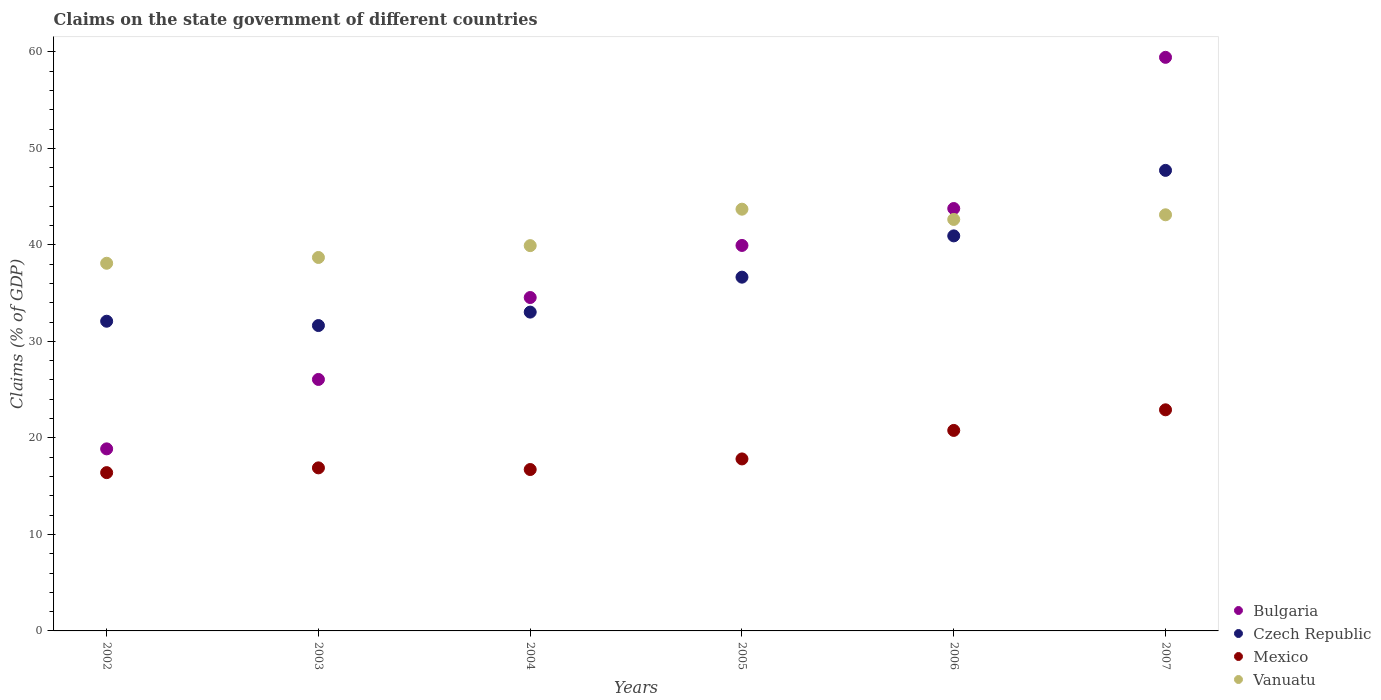What is the percentage of GDP claimed on the state government in Vanuatu in 2003?
Provide a short and direct response. 38.69. Across all years, what is the maximum percentage of GDP claimed on the state government in Czech Republic?
Offer a very short reply. 47.72. Across all years, what is the minimum percentage of GDP claimed on the state government in Czech Republic?
Provide a succinct answer. 31.64. What is the total percentage of GDP claimed on the state government in Czech Republic in the graph?
Keep it short and to the point. 222.06. What is the difference between the percentage of GDP claimed on the state government in Vanuatu in 2002 and that in 2006?
Make the answer very short. -4.54. What is the difference between the percentage of GDP claimed on the state government in Mexico in 2002 and the percentage of GDP claimed on the state government in Vanuatu in 2007?
Your response must be concise. -26.72. What is the average percentage of GDP claimed on the state government in Mexico per year?
Provide a succinct answer. 18.59. In the year 2003, what is the difference between the percentage of GDP claimed on the state government in Bulgaria and percentage of GDP claimed on the state government in Czech Republic?
Your response must be concise. -5.58. In how many years, is the percentage of GDP claimed on the state government in Czech Republic greater than 22 %?
Provide a short and direct response. 6. What is the ratio of the percentage of GDP claimed on the state government in Mexico in 2002 to that in 2006?
Your answer should be compact. 0.79. Is the percentage of GDP claimed on the state government in Mexico in 2004 less than that in 2007?
Provide a succinct answer. Yes. What is the difference between the highest and the second highest percentage of GDP claimed on the state government in Bulgaria?
Offer a very short reply. 15.66. What is the difference between the highest and the lowest percentage of GDP claimed on the state government in Czech Republic?
Provide a succinct answer. 16.08. Is the percentage of GDP claimed on the state government in Czech Republic strictly less than the percentage of GDP claimed on the state government in Vanuatu over the years?
Provide a succinct answer. No. How many dotlines are there?
Offer a terse response. 4. What is the difference between two consecutive major ticks on the Y-axis?
Your response must be concise. 10. Are the values on the major ticks of Y-axis written in scientific E-notation?
Provide a short and direct response. No. Where does the legend appear in the graph?
Make the answer very short. Bottom right. How many legend labels are there?
Provide a succinct answer. 4. What is the title of the graph?
Your answer should be compact. Claims on the state government of different countries. What is the label or title of the Y-axis?
Your response must be concise. Claims (% of GDP). What is the Claims (% of GDP) in Bulgaria in 2002?
Your response must be concise. 18.86. What is the Claims (% of GDP) of Czech Republic in 2002?
Offer a terse response. 32.09. What is the Claims (% of GDP) of Mexico in 2002?
Make the answer very short. 16.4. What is the Claims (% of GDP) in Vanuatu in 2002?
Keep it short and to the point. 38.09. What is the Claims (% of GDP) of Bulgaria in 2003?
Provide a succinct answer. 26.06. What is the Claims (% of GDP) of Czech Republic in 2003?
Make the answer very short. 31.64. What is the Claims (% of GDP) in Mexico in 2003?
Your response must be concise. 16.89. What is the Claims (% of GDP) of Vanuatu in 2003?
Provide a short and direct response. 38.69. What is the Claims (% of GDP) of Bulgaria in 2004?
Ensure brevity in your answer.  34.54. What is the Claims (% of GDP) in Czech Republic in 2004?
Offer a terse response. 33.03. What is the Claims (% of GDP) of Mexico in 2004?
Your answer should be very brief. 16.72. What is the Claims (% of GDP) in Vanuatu in 2004?
Your answer should be compact. 39.92. What is the Claims (% of GDP) in Bulgaria in 2005?
Offer a terse response. 39.94. What is the Claims (% of GDP) in Czech Republic in 2005?
Provide a short and direct response. 36.65. What is the Claims (% of GDP) of Mexico in 2005?
Ensure brevity in your answer.  17.82. What is the Claims (% of GDP) in Vanuatu in 2005?
Ensure brevity in your answer.  43.7. What is the Claims (% of GDP) of Bulgaria in 2006?
Make the answer very short. 43.77. What is the Claims (% of GDP) of Czech Republic in 2006?
Offer a terse response. 40.93. What is the Claims (% of GDP) in Mexico in 2006?
Your response must be concise. 20.77. What is the Claims (% of GDP) in Vanuatu in 2006?
Provide a short and direct response. 42.63. What is the Claims (% of GDP) in Bulgaria in 2007?
Give a very brief answer. 59.43. What is the Claims (% of GDP) of Czech Republic in 2007?
Ensure brevity in your answer.  47.72. What is the Claims (% of GDP) of Mexico in 2007?
Provide a succinct answer. 22.91. What is the Claims (% of GDP) of Vanuatu in 2007?
Your response must be concise. 43.12. Across all years, what is the maximum Claims (% of GDP) in Bulgaria?
Provide a short and direct response. 59.43. Across all years, what is the maximum Claims (% of GDP) in Czech Republic?
Provide a succinct answer. 47.72. Across all years, what is the maximum Claims (% of GDP) of Mexico?
Give a very brief answer. 22.91. Across all years, what is the maximum Claims (% of GDP) in Vanuatu?
Your answer should be very brief. 43.7. Across all years, what is the minimum Claims (% of GDP) in Bulgaria?
Your answer should be compact. 18.86. Across all years, what is the minimum Claims (% of GDP) in Czech Republic?
Your response must be concise. 31.64. Across all years, what is the minimum Claims (% of GDP) in Mexico?
Keep it short and to the point. 16.4. Across all years, what is the minimum Claims (% of GDP) in Vanuatu?
Your response must be concise. 38.09. What is the total Claims (% of GDP) in Bulgaria in the graph?
Offer a very short reply. 222.6. What is the total Claims (% of GDP) in Czech Republic in the graph?
Your response must be concise. 222.06. What is the total Claims (% of GDP) in Mexico in the graph?
Give a very brief answer. 111.52. What is the total Claims (% of GDP) of Vanuatu in the graph?
Provide a succinct answer. 246.15. What is the difference between the Claims (% of GDP) of Bulgaria in 2002 and that in 2003?
Make the answer very short. -7.19. What is the difference between the Claims (% of GDP) of Czech Republic in 2002 and that in 2003?
Your response must be concise. 0.45. What is the difference between the Claims (% of GDP) in Mexico in 2002 and that in 2003?
Make the answer very short. -0.49. What is the difference between the Claims (% of GDP) of Vanuatu in 2002 and that in 2003?
Provide a succinct answer. -0.6. What is the difference between the Claims (% of GDP) of Bulgaria in 2002 and that in 2004?
Ensure brevity in your answer.  -15.68. What is the difference between the Claims (% of GDP) of Czech Republic in 2002 and that in 2004?
Your answer should be compact. -0.94. What is the difference between the Claims (% of GDP) of Mexico in 2002 and that in 2004?
Provide a succinct answer. -0.32. What is the difference between the Claims (% of GDP) of Vanuatu in 2002 and that in 2004?
Make the answer very short. -1.83. What is the difference between the Claims (% of GDP) in Bulgaria in 2002 and that in 2005?
Offer a very short reply. -21.08. What is the difference between the Claims (% of GDP) in Czech Republic in 2002 and that in 2005?
Give a very brief answer. -4.57. What is the difference between the Claims (% of GDP) in Mexico in 2002 and that in 2005?
Provide a short and direct response. -1.42. What is the difference between the Claims (% of GDP) of Vanuatu in 2002 and that in 2005?
Your response must be concise. -5.6. What is the difference between the Claims (% of GDP) in Bulgaria in 2002 and that in 2006?
Offer a terse response. -24.9. What is the difference between the Claims (% of GDP) of Czech Republic in 2002 and that in 2006?
Ensure brevity in your answer.  -8.84. What is the difference between the Claims (% of GDP) in Mexico in 2002 and that in 2006?
Your answer should be very brief. -4.37. What is the difference between the Claims (% of GDP) in Vanuatu in 2002 and that in 2006?
Your answer should be compact. -4.54. What is the difference between the Claims (% of GDP) of Bulgaria in 2002 and that in 2007?
Offer a very short reply. -40.57. What is the difference between the Claims (% of GDP) of Czech Republic in 2002 and that in 2007?
Provide a succinct answer. -15.63. What is the difference between the Claims (% of GDP) of Mexico in 2002 and that in 2007?
Give a very brief answer. -6.51. What is the difference between the Claims (% of GDP) in Vanuatu in 2002 and that in 2007?
Provide a succinct answer. -5.02. What is the difference between the Claims (% of GDP) of Bulgaria in 2003 and that in 2004?
Offer a terse response. -8.49. What is the difference between the Claims (% of GDP) of Czech Republic in 2003 and that in 2004?
Provide a short and direct response. -1.39. What is the difference between the Claims (% of GDP) in Mexico in 2003 and that in 2004?
Make the answer very short. 0.17. What is the difference between the Claims (% of GDP) of Vanuatu in 2003 and that in 2004?
Your answer should be compact. -1.23. What is the difference between the Claims (% of GDP) in Bulgaria in 2003 and that in 2005?
Provide a short and direct response. -13.88. What is the difference between the Claims (% of GDP) of Czech Republic in 2003 and that in 2005?
Offer a very short reply. -5.01. What is the difference between the Claims (% of GDP) of Mexico in 2003 and that in 2005?
Give a very brief answer. -0.93. What is the difference between the Claims (% of GDP) of Vanuatu in 2003 and that in 2005?
Provide a succinct answer. -5. What is the difference between the Claims (% of GDP) in Bulgaria in 2003 and that in 2006?
Ensure brevity in your answer.  -17.71. What is the difference between the Claims (% of GDP) of Czech Republic in 2003 and that in 2006?
Your answer should be compact. -9.29. What is the difference between the Claims (% of GDP) of Mexico in 2003 and that in 2006?
Offer a terse response. -3.88. What is the difference between the Claims (% of GDP) of Vanuatu in 2003 and that in 2006?
Provide a short and direct response. -3.94. What is the difference between the Claims (% of GDP) in Bulgaria in 2003 and that in 2007?
Make the answer very short. -33.37. What is the difference between the Claims (% of GDP) in Czech Republic in 2003 and that in 2007?
Keep it short and to the point. -16.08. What is the difference between the Claims (% of GDP) of Mexico in 2003 and that in 2007?
Give a very brief answer. -6.02. What is the difference between the Claims (% of GDP) of Vanuatu in 2003 and that in 2007?
Keep it short and to the point. -4.42. What is the difference between the Claims (% of GDP) in Bulgaria in 2004 and that in 2005?
Your answer should be compact. -5.4. What is the difference between the Claims (% of GDP) in Czech Republic in 2004 and that in 2005?
Make the answer very short. -3.62. What is the difference between the Claims (% of GDP) in Mexico in 2004 and that in 2005?
Ensure brevity in your answer.  -1.1. What is the difference between the Claims (% of GDP) in Vanuatu in 2004 and that in 2005?
Give a very brief answer. -3.78. What is the difference between the Claims (% of GDP) in Bulgaria in 2004 and that in 2006?
Provide a short and direct response. -9.22. What is the difference between the Claims (% of GDP) of Czech Republic in 2004 and that in 2006?
Give a very brief answer. -7.9. What is the difference between the Claims (% of GDP) of Mexico in 2004 and that in 2006?
Give a very brief answer. -4.05. What is the difference between the Claims (% of GDP) of Vanuatu in 2004 and that in 2006?
Keep it short and to the point. -2.71. What is the difference between the Claims (% of GDP) in Bulgaria in 2004 and that in 2007?
Your answer should be compact. -24.89. What is the difference between the Claims (% of GDP) in Czech Republic in 2004 and that in 2007?
Make the answer very short. -14.68. What is the difference between the Claims (% of GDP) in Mexico in 2004 and that in 2007?
Your answer should be compact. -6.19. What is the difference between the Claims (% of GDP) of Vanuatu in 2004 and that in 2007?
Your answer should be compact. -3.2. What is the difference between the Claims (% of GDP) in Bulgaria in 2005 and that in 2006?
Keep it short and to the point. -3.82. What is the difference between the Claims (% of GDP) of Czech Republic in 2005 and that in 2006?
Your answer should be compact. -4.28. What is the difference between the Claims (% of GDP) in Mexico in 2005 and that in 2006?
Make the answer very short. -2.95. What is the difference between the Claims (% of GDP) in Vanuatu in 2005 and that in 2006?
Offer a very short reply. 1.06. What is the difference between the Claims (% of GDP) of Bulgaria in 2005 and that in 2007?
Ensure brevity in your answer.  -19.49. What is the difference between the Claims (% of GDP) of Czech Republic in 2005 and that in 2007?
Your answer should be very brief. -11.06. What is the difference between the Claims (% of GDP) of Mexico in 2005 and that in 2007?
Your response must be concise. -5.09. What is the difference between the Claims (% of GDP) of Vanuatu in 2005 and that in 2007?
Ensure brevity in your answer.  0.58. What is the difference between the Claims (% of GDP) in Bulgaria in 2006 and that in 2007?
Your answer should be compact. -15.66. What is the difference between the Claims (% of GDP) of Czech Republic in 2006 and that in 2007?
Give a very brief answer. -6.79. What is the difference between the Claims (% of GDP) in Mexico in 2006 and that in 2007?
Your answer should be compact. -2.14. What is the difference between the Claims (% of GDP) of Vanuatu in 2006 and that in 2007?
Your response must be concise. -0.48. What is the difference between the Claims (% of GDP) of Bulgaria in 2002 and the Claims (% of GDP) of Czech Republic in 2003?
Your answer should be compact. -12.78. What is the difference between the Claims (% of GDP) in Bulgaria in 2002 and the Claims (% of GDP) in Mexico in 2003?
Your answer should be compact. 1.97. What is the difference between the Claims (% of GDP) of Bulgaria in 2002 and the Claims (% of GDP) of Vanuatu in 2003?
Keep it short and to the point. -19.83. What is the difference between the Claims (% of GDP) of Czech Republic in 2002 and the Claims (% of GDP) of Mexico in 2003?
Ensure brevity in your answer.  15.19. What is the difference between the Claims (% of GDP) of Czech Republic in 2002 and the Claims (% of GDP) of Vanuatu in 2003?
Your answer should be very brief. -6.61. What is the difference between the Claims (% of GDP) of Mexico in 2002 and the Claims (% of GDP) of Vanuatu in 2003?
Your answer should be very brief. -22.29. What is the difference between the Claims (% of GDP) in Bulgaria in 2002 and the Claims (% of GDP) in Czech Republic in 2004?
Your answer should be very brief. -14.17. What is the difference between the Claims (% of GDP) in Bulgaria in 2002 and the Claims (% of GDP) in Mexico in 2004?
Your answer should be compact. 2.14. What is the difference between the Claims (% of GDP) in Bulgaria in 2002 and the Claims (% of GDP) in Vanuatu in 2004?
Provide a succinct answer. -21.06. What is the difference between the Claims (% of GDP) of Czech Republic in 2002 and the Claims (% of GDP) of Mexico in 2004?
Give a very brief answer. 15.37. What is the difference between the Claims (% of GDP) of Czech Republic in 2002 and the Claims (% of GDP) of Vanuatu in 2004?
Provide a succinct answer. -7.83. What is the difference between the Claims (% of GDP) of Mexico in 2002 and the Claims (% of GDP) of Vanuatu in 2004?
Provide a short and direct response. -23.52. What is the difference between the Claims (% of GDP) in Bulgaria in 2002 and the Claims (% of GDP) in Czech Republic in 2005?
Provide a short and direct response. -17.79. What is the difference between the Claims (% of GDP) in Bulgaria in 2002 and the Claims (% of GDP) in Mexico in 2005?
Make the answer very short. 1.04. What is the difference between the Claims (% of GDP) of Bulgaria in 2002 and the Claims (% of GDP) of Vanuatu in 2005?
Keep it short and to the point. -24.83. What is the difference between the Claims (% of GDP) of Czech Republic in 2002 and the Claims (% of GDP) of Mexico in 2005?
Give a very brief answer. 14.27. What is the difference between the Claims (% of GDP) of Czech Republic in 2002 and the Claims (% of GDP) of Vanuatu in 2005?
Make the answer very short. -11.61. What is the difference between the Claims (% of GDP) in Mexico in 2002 and the Claims (% of GDP) in Vanuatu in 2005?
Provide a succinct answer. -27.3. What is the difference between the Claims (% of GDP) in Bulgaria in 2002 and the Claims (% of GDP) in Czech Republic in 2006?
Keep it short and to the point. -22.07. What is the difference between the Claims (% of GDP) in Bulgaria in 2002 and the Claims (% of GDP) in Mexico in 2006?
Your answer should be compact. -1.91. What is the difference between the Claims (% of GDP) of Bulgaria in 2002 and the Claims (% of GDP) of Vanuatu in 2006?
Offer a very short reply. -23.77. What is the difference between the Claims (% of GDP) of Czech Republic in 2002 and the Claims (% of GDP) of Mexico in 2006?
Offer a very short reply. 11.31. What is the difference between the Claims (% of GDP) of Czech Republic in 2002 and the Claims (% of GDP) of Vanuatu in 2006?
Keep it short and to the point. -10.55. What is the difference between the Claims (% of GDP) of Mexico in 2002 and the Claims (% of GDP) of Vanuatu in 2006?
Give a very brief answer. -26.23. What is the difference between the Claims (% of GDP) of Bulgaria in 2002 and the Claims (% of GDP) of Czech Republic in 2007?
Make the answer very short. -28.86. What is the difference between the Claims (% of GDP) in Bulgaria in 2002 and the Claims (% of GDP) in Mexico in 2007?
Offer a very short reply. -4.05. What is the difference between the Claims (% of GDP) of Bulgaria in 2002 and the Claims (% of GDP) of Vanuatu in 2007?
Your answer should be compact. -24.25. What is the difference between the Claims (% of GDP) of Czech Republic in 2002 and the Claims (% of GDP) of Mexico in 2007?
Your response must be concise. 9.18. What is the difference between the Claims (% of GDP) in Czech Republic in 2002 and the Claims (% of GDP) in Vanuatu in 2007?
Your response must be concise. -11.03. What is the difference between the Claims (% of GDP) of Mexico in 2002 and the Claims (% of GDP) of Vanuatu in 2007?
Your response must be concise. -26.72. What is the difference between the Claims (% of GDP) of Bulgaria in 2003 and the Claims (% of GDP) of Czech Republic in 2004?
Give a very brief answer. -6.98. What is the difference between the Claims (% of GDP) of Bulgaria in 2003 and the Claims (% of GDP) of Mexico in 2004?
Offer a very short reply. 9.33. What is the difference between the Claims (% of GDP) in Bulgaria in 2003 and the Claims (% of GDP) in Vanuatu in 2004?
Offer a terse response. -13.86. What is the difference between the Claims (% of GDP) of Czech Republic in 2003 and the Claims (% of GDP) of Mexico in 2004?
Provide a succinct answer. 14.92. What is the difference between the Claims (% of GDP) of Czech Republic in 2003 and the Claims (% of GDP) of Vanuatu in 2004?
Your answer should be compact. -8.28. What is the difference between the Claims (% of GDP) in Mexico in 2003 and the Claims (% of GDP) in Vanuatu in 2004?
Make the answer very short. -23.03. What is the difference between the Claims (% of GDP) of Bulgaria in 2003 and the Claims (% of GDP) of Czech Republic in 2005?
Offer a very short reply. -10.6. What is the difference between the Claims (% of GDP) in Bulgaria in 2003 and the Claims (% of GDP) in Mexico in 2005?
Your response must be concise. 8.23. What is the difference between the Claims (% of GDP) in Bulgaria in 2003 and the Claims (% of GDP) in Vanuatu in 2005?
Offer a very short reply. -17.64. What is the difference between the Claims (% of GDP) in Czech Republic in 2003 and the Claims (% of GDP) in Mexico in 2005?
Provide a short and direct response. 13.82. What is the difference between the Claims (% of GDP) of Czech Republic in 2003 and the Claims (% of GDP) of Vanuatu in 2005?
Provide a short and direct response. -12.06. What is the difference between the Claims (% of GDP) of Mexico in 2003 and the Claims (% of GDP) of Vanuatu in 2005?
Provide a succinct answer. -26.8. What is the difference between the Claims (% of GDP) in Bulgaria in 2003 and the Claims (% of GDP) in Czech Republic in 2006?
Your response must be concise. -14.88. What is the difference between the Claims (% of GDP) in Bulgaria in 2003 and the Claims (% of GDP) in Mexico in 2006?
Your answer should be compact. 5.28. What is the difference between the Claims (% of GDP) in Bulgaria in 2003 and the Claims (% of GDP) in Vanuatu in 2006?
Ensure brevity in your answer.  -16.58. What is the difference between the Claims (% of GDP) of Czech Republic in 2003 and the Claims (% of GDP) of Mexico in 2006?
Offer a terse response. 10.87. What is the difference between the Claims (% of GDP) in Czech Republic in 2003 and the Claims (% of GDP) in Vanuatu in 2006?
Keep it short and to the point. -10.99. What is the difference between the Claims (% of GDP) of Mexico in 2003 and the Claims (% of GDP) of Vanuatu in 2006?
Give a very brief answer. -25.74. What is the difference between the Claims (% of GDP) in Bulgaria in 2003 and the Claims (% of GDP) in Czech Republic in 2007?
Your answer should be very brief. -21.66. What is the difference between the Claims (% of GDP) in Bulgaria in 2003 and the Claims (% of GDP) in Mexico in 2007?
Your answer should be very brief. 3.15. What is the difference between the Claims (% of GDP) of Bulgaria in 2003 and the Claims (% of GDP) of Vanuatu in 2007?
Give a very brief answer. -17.06. What is the difference between the Claims (% of GDP) in Czech Republic in 2003 and the Claims (% of GDP) in Mexico in 2007?
Give a very brief answer. 8.73. What is the difference between the Claims (% of GDP) in Czech Republic in 2003 and the Claims (% of GDP) in Vanuatu in 2007?
Keep it short and to the point. -11.48. What is the difference between the Claims (% of GDP) of Mexico in 2003 and the Claims (% of GDP) of Vanuatu in 2007?
Offer a very short reply. -26.22. What is the difference between the Claims (% of GDP) in Bulgaria in 2004 and the Claims (% of GDP) in Czech Republic in 2005?
Your answer should be compact. -2.11. What is the difference between the Claims (% of GDP) of Bulgaria in 2004 and the Claims (% of GDP) of Mexico in 2005?
Your answer should be compact. 16.72. What is the difference between the Claims (% of GDP) in Bulgaria in 2004 and the Claims (% of GDP) in Vanuatu in 2005?
Provide a short and direct response. -9.15. What is the difference between the Claims (% of GDP) of Czech Republic in 2004 and the Claims (% of GDP) of Mexico in 2005?
Make the answer very short. 15.21. What is the difference between the Claims (% of GDP) in Czech Republic in 2004 and the Claims (% of GDP) in Vanuatu in 2005?
Your response must be concise. -10.66. What is the difference between the Claims (% of GDP) of Mexico in 2004 and the Claims (% of GDP) of Vanuatu in 2005?
Provide a succinct answer. -26.97. What is the difference between the Claims (% of GDP) in Bulgaria in 2004 and the Claims (% of GDP) in Czech Republic in 2006?
Ensure brevity in your answer.  -6.39. What is the difference between the Claims (% of GDP) of Bulgaria in 2004 and the Claims (% of GDP) of Mexico in 2006?
Provide a short and direct response. 13.77. What is the difference between the Claims (% of GDP) in Bulgaria in 2004 and the Claims (% of GDP) in Vanuatu in 2006?
Ensure brevity in your answer.  -8.09. What is the difference between the Claims (% of GDP) of Czech Republic in 2004 and the Claims (% of GDP) of Mexico in 2006?
Keep it short and to the point. 12.26. What is the difference between the Claims (% of GDP) in Czech Republic in 2004 and the Claims (% of GDP) in Vanuatu in 2006?
Make the answer very short. -9.6. What is the difference between the Claims (% of GDP) in Mexico in 2004 and the Claims (% of GDP) in Vanuatu in 2006?
Ensure brevity in your answer.  -25.91. What is the difference between the Claims (% of GDP) in Bulgaria in 2004 and the Claims (% of GDP) in Czech Republic in 2007?
Make the answer very short. -13.17. What is the difference between the Claims (% of GDP) in Bulgaria in 2004 and the Claims (% of GDP) in Mexico in 2007?
Your answer should be very brief. 11.63. What is the difference between the Claims (% of GDP) in Bulgaria in 2004 and the Claims (% of GDP) in Vanuatu in 2007?
Give a very brief answer. -8.57. What is the difference between the Claims (% of GDP) of Czech Republic in 2004 and the Claims (% of GDP) of Mexico in 2007?
Keep it short and to the point. 10.12. What is the difference between the Claims (% of GDP) in Czech Republic in 2004 and the Claims (% of GDP) in Vanuatu in 2007?
Provide a succinct answer. -10.08. What is the difference between the Claims (% of GDP) in Mexico in 2004 and the Claims (% of GDP) in Vanuatu in 2007?
Keep it short and to the point. -26.39. What is the difference between the Claims (% of GDP) of Bulgaria in 2005 and the Claims (% of GDP) of Czech Republic in 2006?
Offer a terse response. -0.99. What is the difference between the Claims (% of GDP) of Bulgaria in 2005 and the Claims (% of GDP) of Mexico in 2006?
Your answer should be compact. 19.17. What is the difference between the Claims (% of GDP) in Bulgaria in 2005 and the Claims (% of GDP) in Vanuatu in 2006?
Ensure brevity in your answer.  -2.69. What is the difference between the Claims (% of GDP) in Czech Republic in 2005 and the Claims (% of GDP) in Mexico in 2006?
Offer a very short reply. 15.88. What is the difference between the Claims (% of GDP) of Czech Republic in 2005 and the Claims (% of GDP) of Vanuatu in 2006?
Offer a very short reply. -5.98. What is the difference between the Claims (% of GDP) in Mexico in 2005 and the Claims (% of GDP) in Vanuatu in 2006?
Keep it short and to the point. -24.81. What is the difference between the Claims (% of GDP) in Bulgaria in 2005 and the Claims (% of GDP) in Czech Republic in 2007?
Give a very brief answer. -7.78. What is the difference between the Claims (% of GDP) in Bulgaria in 2005 and the Claims (% of GDP) in Mexico in 2007?
Provide a succinct answer. 17.03. What is the difference between the Claims (% of GDP) of Bulgaria in 2005 and the Claims (% of GDP) of Vanuatu in 2007?
Keep it short and to the point. -3.18. What is the difference between the Claims (% of GDP) of Czech Republic in 2005 and the Claims (% of GDP) of Mexico in 2007?
Keep it short and to the point. 13.74. What is the difference between the Claims (% of GDP) in Czech Republic in 2005 and the Claims (% of GDP) in Vanuatu in 2007?
Ensure brevity in your answer.  -6.46. What is the difference between the Claims (% of GDP) in Mexico in 2005 and the Claims (% of GDP) in Vanuatu in 2007?
Offer a terse response. -25.29. What is the difference between the Claims (% of GDP) in Bulgaria in 2006 and the Claims (% of GDP) in Czech Republic in 2007?
Your answer should be compact. -3.95. What is the difference between the Claims (% of GDP) of Bulgaria in 2006 and the Claims (% of GDP) of Mexico in 2007?
Your answer should be compact. 20.86. What is the difference between the Claims (% of GDP) of Bulgaria in 2006 and the Claims (% of GDP) of Vanuatu in 2007?
Provide a succinct answer. 0.65. What is the difference between the Claims (% of GDP) of Czech Republic in 2006 and the Claims (% of GDP) of Mexico in 2007?
Provide a succinct answer. 18.02. What is the difference between the Claims (% of GDP) in Czech Republic in 2006 and the Claims (% of GDP) in Vanuatu in 2007?
Your response must be concise. -2.18. What is the difference between the Claims (% of GDP) in Mexico in 2006 and the Claims (% of GDP) in Vanuatu in 2007?
Provide a short and direct response. -22.34. What is the average Claims (% of GDP) of Bulgaria per year?
Keep it short and to the point. 37.1. What is the average Claims (% of GDP) in Czech Republic per year?
Keep it short and to the point. 37.01. What is the average Claims (% of GDP) of Mexico per year?
Your answer should be very brief. 18.59. What is the average Claims (% of GDP) in Vanuatu per year?
Offer a very short reply. 41.03. In the year 2002, what is the difference between the Claims (% of GDP) in Bulgaria and Claims (% of GDP) in Czech Republic?
Your answer should be compact. -13.23. In the year 2002, what is the difference between the Claims (% of GDP) of Bulgaria and Claims (% of GDP) of Mexico?
Give a very brief answer. 2.46. In the year 2002, what is the difference between the Claims (% of GDP) of Bulgaria and Claims (% of GDP) of Vanuatu?
Keep it short and to the point. -19.23. In the year 2002, what is the difference between the Claims (% of GDP) of Czech Republic and Claims (% of GDP) of Mexico?
Give a very brief answer. 15.69. In the year 2002, what is the difference between the Claims (% of GDP) of Czech Republic and Claims (% of GDP) of Vanuatu?
Offer a very short reply. -6.01. In the year 2002, what is the difference between the Claims (% of GDP) in Mexico and Claims (% of GDP) in Vanuatu?
Provide a succinct answer. -21.69. In the year 2003, what is the difference between the Claims (% of GDP) in Bulgaria and Claims (% of GDP) in Czech Republic?
Offer a terse response. -5.58. In the year 2003, what is the difference between the Claims (% of GDP) in Bulgaria and Claims (% of GDP) in Mexico?
Offer a terse response. 9.16. In the year 2003, what is the difference between the Claims (% of GDP) in Bulgaria and Claims (% of GDP) in Vanuatu?
Your answer should be very brief. -12.64. In the year 2003, what is the difference between the Claims (% of GDP) of Czech Republic and Claims (% of GDP) of Mexico?
Your answer should be very brief. 14.75. In the year 2003, what is the difference between the Claims (% of GDP) of Czech Republic and Claims (% of GDP) of Vanuatu?
Give a very brief answer. -7.05. In the year 2003, what is the difference between the Claims (% of GDP) in Mexico and Claims (% of GDP) in Vanuatu?
Your answer should be very brief. -21.8. In the year 2004, what is the difference between the Claims (% of GDP) in Bulgaria and Claims (% of GDP) in Czech Republic?
Your answer should be very brief. 1.51. In the year 2004, what is the difference between the Claims (% of GDP) of Bulgaria and Claims (% of GDP) of Mexico?
Ensure brevity in your answer.  17.82. In the year 2004, what is the difference between the Claims (% of GDP) of Bulgaria and Claims (% of GDP) of Vanuatu?
Provide a succinct answer. -5.38. In the year 2004, what is the difference between the Claims (% of GDP) in Czech Republic and Claims (% of GDP) in Mexico?
Provide a short and direct response. 16.31. In the year 2004, what is the difference between the Claims (% of GDP) in Czech Republic and Claims (% of GDP) in Vanuatu?
Your answer should be compact. -6.89. In the year 2004, what is the difference between the Claims (% of GDP) in Mexico and Claims (% of GDP) in Vanuatu?
Your answer should be compact. -23.2. In the year 2005, what is the difference between the Claims (% of GDP) in Bulgaria and Claims (% of GDP) in Czech Republic?
Make the answer very short. 3.29. In the year 2005, what is the difference between the Claims (% of GDP) of Bulgaria and Claims (% of GDP) of Mexico?
Offer a terse response. 22.12. In the year 2005, what is the difference between the Claims (% of GDP) in Bulgaria and Claims (% of GDP) in Vanuatu?
Provide a short and direct response. -3.76. In the year 2005, what is the difference between the Claims (% of GDP) of Czech Republic and Claims (% of GDP) of Mexico?
Ensure brevity in your answer.  18.83. In the year 2005, what is the difference between the Claims (% of GDP) in Czech Republic and Claims (% of GDP) in Vanuatu?
Your answer should be compact. -7.04. In the year 2005, what is the difference between the Claims (% of GDP) of Mexico and Claims (% of GDP) of Vanuatu?
Your response must be concise. -25.88. In the year 2006, what is the difference between the Claims (% of GDP) in Bulgaria and Claims (% of GDP) in Czech Republic?
Make the answer very short. 2.83. In the year 2006, what is the difference between the Claims (% of GDP) in Bulgaria and Claims (% of GDP) in Mexico?
Provide a short and direct response. 22.99. In the year 2006, what is the difference between the Claims (% of GDP) of Bulgaria and Claims (% of GDP) of Vanuatu?
Keep it short and to the point. 1.13. In the year 2006, what is the difference between the Claims (% of GDP) of Czech Republic and Claims (% of GDP) of Mexico?
Give a very brief answer. 20.16. In the year 2006, what is the difference between the Claims (% of GDP) in Czech Republic and Claims (% of GDP) in Vanuatu?
Your response must be concise. -1.7. In the year 2006, what is the difference between the Claims (% of GDP) of Mexico and Claims (% of GDP) of Vanuatu?
Your response must be concise. -21.86. In the year 2007, what is the difference between the Claims (% of GDP) in Bulgaria and Claims (% of GDP) in Czech Republic?
Your response must be concise. 11.71. In the year 2007, what is the difference between the Claims (% of GDP) of Bulgaria and Claims (% of GDP) of Mexico?
Provide a short and direct response. 36.52. In the year 2007, what is the difference between the Claims (% of GDP) in Bulgaria and Claims (% of GDP) in Vanuatu?
Offer a terse response. 16.31. In the year 2007, what is the difference between the Claims (% of GDP) in Czech Republic and Claims (% of GDP) in Mexico?
Your answer should be very brief. 24.81. In the year 2007, what is the difference between the Claims (% of GDP) in Czech Republic and Claims (% of GDP) in Vanuatu?
Your response must be concise. 4.6. In the year 2007, what is the difference between the Claims (% of GDP) in Mexico and Claims (% of GDP) in Vanuatu?
Your answer should be very brief. -20.21. What is the ratio of the Claims (% of GDP) of Bulgaria in 2002 to that in 2003?
Offer a terse response. 0.72. What is the ratio of the Claims (% of GDP) of Czech Republic in 2002 to that in 2003?
Make the answer very short. 1.01. What is the ratio of the Claims (% of GDP) of Mexico in 2002 to that in 2003?
Your answer should be compact. 0.97. What is the ratio of the Claims (% of GDP) of Vanuatu in 2002 to that in 2003?
Keep it short and to the point. 0.98. What is the ratio of the Claims (% of GDP) of Bulgaria in 2002 to that in 2004?
Offer a very short reply. 0.55. What is the ratio of the Claims (% of GDP) in Czech Republic in 2002 to that in 2004?
Make the answer very short. 0.97. What is the ratio of the Claims (% of GDP) of Mexico in 2002 to that in 2004?
Ensure brevity in your answer.  0.98. What is the ratio of the Claims (% of GDP) in Vanuatu in 2002 to that in 2004?
Provide a succinct answer. 0.95. What is the ratio of the Claims (% of GDP) in Bulgaria in 2002 to that in 2005?
Give a very brief answer. 0.47. What is the ratio of the Claims (% of GDP) in Czech Republic in 2002 to that in 2005?
Offer a very short reply. 0.88. What is the ratio of the Claims (% of GDP) in Mexico in 2002 to that in 2005?
Your answer should be compact. 0.92. What is the ratio of the Claims (% of GDP) in Vanuatu in 2002 to that in 2005?
Keep it short and to the point. 0.87. What is the ratio of the Claims (% of GDP) of Bulgaria in 2002 to that in 2006?
Offer a terse response. 0.43. What is the ratio of the Claims (% of GDP) in Czech Republic in 2002 to that in 2006?
Provide a succinct answer. 0.78. What is the ratio of the Claims (% of GDP) of Mexico in 2002 to that in 2006?
Your answer should be very brief. 0.79. What is the ratio of the Claims (% of GDP) of Vanuatu in 2002 to that in 2006?
Offer a very short reply. 0.89. What is the ratio of the Claims (% of GDP) of Bulgaria in 2002 to that in 2007?
Give a very brief answer. 0.32. What is the ratio of the Claims (% of GDP) in Czech Republic in 2002 to that in 2007?
Offer a terse response. 0.67. What is the ratio of the Claims (% of GDP) of Mexico in 2002 to that in 2007?
Offer a very short reply. 0.72. What is the ratio of the Claims (% of GDP) of Vanuatu in 2002 to that in 2007?
Ensure brevity in your answer.  0.88. What is the ratio of the Claims (% of GDP) in Bulgaria in 2003 to that in 2004?
Keep it short and to the point. 0.75. What is the ratio of the Claims (% of GDP) of Czech Republic in 2003 to that in 2004?
Your answer should be very brief. 0.96. What is the ratio of the Claims (% of GDP) in Mexico in 2003 to that in 2004?
Your answer should be compact. 1.01. What is the ratio of the Claims (% of GDP) in Vanuatu in 2003 to that in 2004?
Your answer should be compact. 0.97. What is the ratio of the Claims (% of GDP) of Bulgaria in 2003 to that in 2005?
Keep it short and to the point. 0.65. What is the ratio of the Claims (% of GDP) in Czech Republic in 2003 to that in 2005?
Offer a very short reply. 0.86. What is the ratio of the Claims (% of GDP) of Mexico in 2003 to that in 2005?
Ensure brevity in your answer.  0.95. What is the ratio of the Claims (% of GDP) in Vanuatu in 2003 to that in 2005?
Ensure brevity in your answer.  0.89. What is the ratio of the Claims (% of GDP) of Bulgaria in 2003 to that in 2006?
Provide a succinct answer. 0.6. What is the ratio of the Claims (% of GDP) of Czech Republic in 2003 to that in 2006?
Provide a short and direct response. 0.77. What is the ratio of the Claims (% of GDP) of Mexico in 2003 to that in 2006?
Ensure brevity in your answer.  0.81. What is the ratio of the Claims (% of GDP) in Vanuatu in 2003 to that in 2006?
Offer a terse response. 0.91. What is the ratio of the Claims (% of GDP) of Bulgaria in 2003 to that in 2007?
Ensure brevity in your answer.  0.44. What is the ratio of the Claims (% of GDP) in Czech Republic in 2003 to that in 2007?
Provide a succinct answer. 0.66. What is the ratio of the Claims (% of GDP) in Mexico in 2003 to that in 2007?
Make the answer very short. 0.74. What is the ratio of the Claims (% of GDP) of Vanuatu in 2003 to that in 2007?
Your answer should be compact. 0.9. What is the ratio of the Claims (% of GDP) of Bulgaria in 2004 to that in 2005?
Your response must be concise. 0.86. What is the ratio of the Claims (% of GDP) in Czech Republic in 2004 to that in 2005?
Keep it short and to the point. 0.9. What is the ratio of the Claims (% of GDP) in Mexico in 2004 to that in 2005?
Provide a short and direct response. 0.94. What is the ratio of the Claims (% of GDP) in Vanuatu in 2004 to that in 2005?
Offer a very short reply. 0.91. What is the ratio of the Claims (% of GDP) of Bulgaria in 2004 to that in 2006?
Your answer should be very brief. 0.79. What is the ratio of the Claims (% of GDP) of Czech Republic in 2004 to that in 2006?
Your answer should be compact. 0.81. What is the ratio of the Claims (% of GDP) in Mexico in 2004 to that in 2006?
Offer a very short reply. 0.81. What is the ratio of the Claims (% of GDP) of Vanuatu in 2004 to that in 2006?
Your answer should be very brief. 0.94. What is the ratio of the Claims (% of GDP) in Bulgaria in 2004 to that in 2007?
Offer a terse response. 0.58. What is the ratio of the Claims (% of GDP) in Czech Republic in 2004 to that in 2007?
Ensure brevity in your answer.  0.69. What is the ratio of the Claims (% of GDP) in Mexico in 2004 to that in 2007?
Make the answer very short. 0.73. What is the ratio of the Claims (% of GDP) in Vanuatu in 2004 to that in 2007?
Provide a succinct answer. 0.93. What is the ratio of the Claims (% of GDP) of Bulgaria in 2005 to that in 2006?
Provide a short and direct response. 0.91. What is the ratio of the Claims (% of GDP) in Czech Republic in 2005 to that in 2006?
Your answer should be very brief. 0.9. What is the ratio of the Claims (% of GDP) of Mexico in 2005 to that in 2006?
Your answer should be very brief. 0.86. What is the ratio of the Claims (% of GDP) in Vanuatu in 2005 to that in 2006?
Provide a short and direct response. 1.02. What is the ratio of the Claims (% of GDP) of Bulgaria in 2005 to that in 2007?
Make the answer very short. 0.67. What is the ratio of the Claims (% of GDP) in Czech Republic in 2005 to that in 2007?
Make the answer very short. 0.77. What is the ratio of the Claims (% of GDP) of Mexico in 2005 to that in 2007?
Provide a short and direct response. 0.78. What is the ratio of the Claims (% of GDP) in Vanuatu in 2005 to that in 2007?
Provide a short and direct response. 1.01. What is the ratio of the Claims (% of GDP) of Bulgaria in 2006 to that in 2007?
Offer a terse response. 0.74. What is the ratio of the Claims (% of GDP) in Czech Republic in 2006 to that in 2007?
Give a very brief answer. 0.86. What is the ratio of the Claims (% of GDP) in Mexico in 2006 to that in 2007?
Your response must be concise. 0.91. What is the difference between the highest and the second highest Claims (% of GDP) in Bulgaria?
Keep it short and to the point. 15.66. What is the difference between the highest and the second highest Claims (% of GDP) in Czech Republic?
Keep it short and to the point. 6.79. What is the difference between the highest and the second highest Claims (% of GDP) in Mexico?
Offer a very short reply. 2.14. What is the difference between the highest and the second highest Claims (% of GDP) of Vanuatu?
Your answer should be very brief. 0.58. What is the difference between the highest and the lowest Claims (% of GDP) of Bulgaria?
Make the answer very short. 40.57. What is the difference between the highest and the lowest Claims (% of GDP) of Czech Republic?
Give a very brief answer. 16.08. What is the difference between the highest and the lowest Claims (% of GDP) of Mexico?
Give a very brief answer. 6.51. What is the difference between the highest and the lowest Claims (% of GDP) in Vanuatu?
Keep it short and to the point. 5.6. 